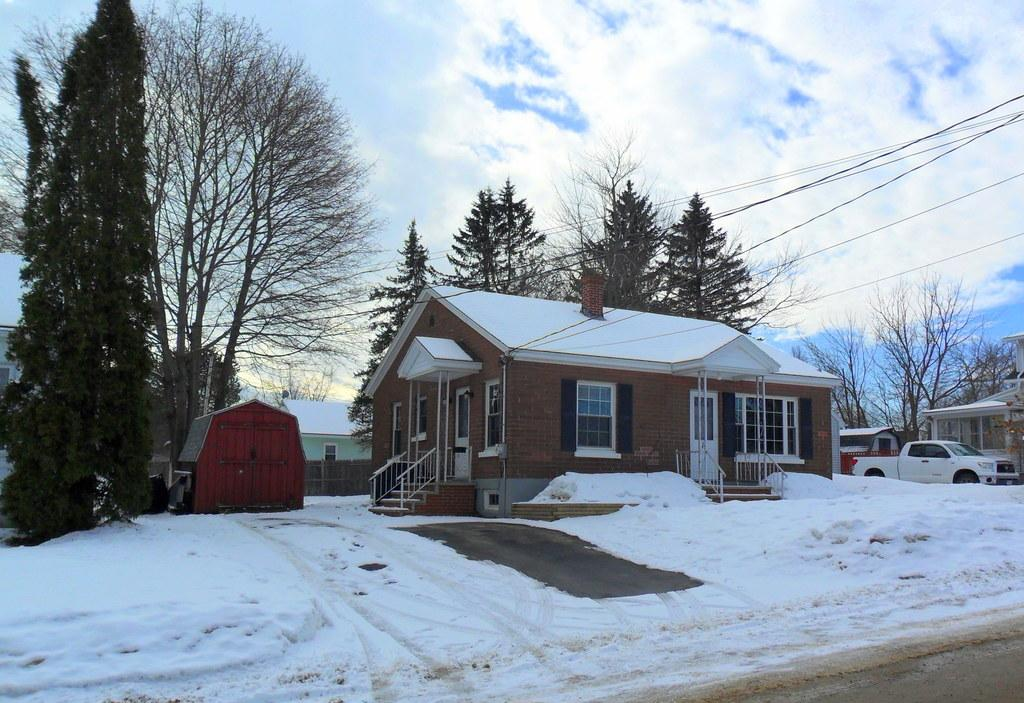What type of structures can be seen in the image? There are houses in the image. What other natural elements are present in the image? There are trees in the image. What man-made objects can be seen in the image? Power line cables are visible in the image. What mode of transportation is present in the image? A vehicle is present in the image. What is visible at the top of the image? The sky is visible at the top of the image. Where can the underwear be found in the image? There is no underwear present in the image. What type of wash is being done in the image? There is no washing activity depicted in the image. 